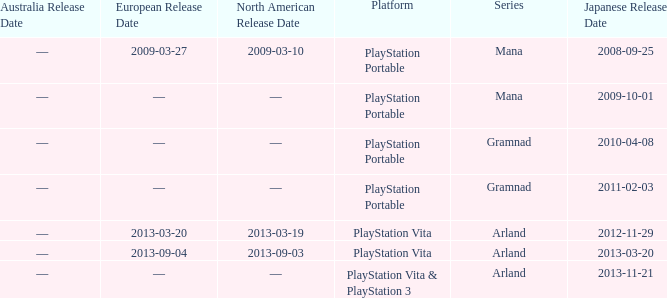What is the series with a North American release date on 2013-09-03? Arland. 